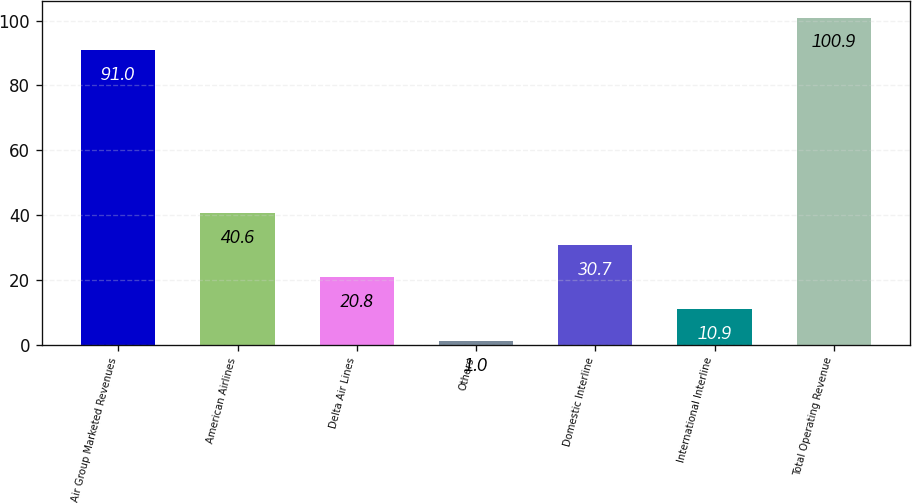Convert chart to OTSL. <chart><loc_0><loc_0><loc_500><loc_500><bar_chart><fcel>Air Group Marketed Revenues<fcel>American Airlines<fcel>Delta Air Lines<fcel>Others<fcel>Domestic Interline<fcel>International Interline<fcel>Total Operating Revenue<nl><fcel>91<fcel>40.6<fcel>20.8<fcel>1<fcel>30.7<fcel>10.9<fcel>100.9<nl></chart> 